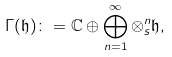Convert formula to latex. <formula><loc_0><loc_0><loc_500><loc_500>\Gamma ( \mathfrak { h } ) \colon = \mathbb { C } \oplus \bigoplus _ { n = 1 } ^ { \infty } \otimes ^ { n } _ { s } \mathfrak { h } ,</formula> 